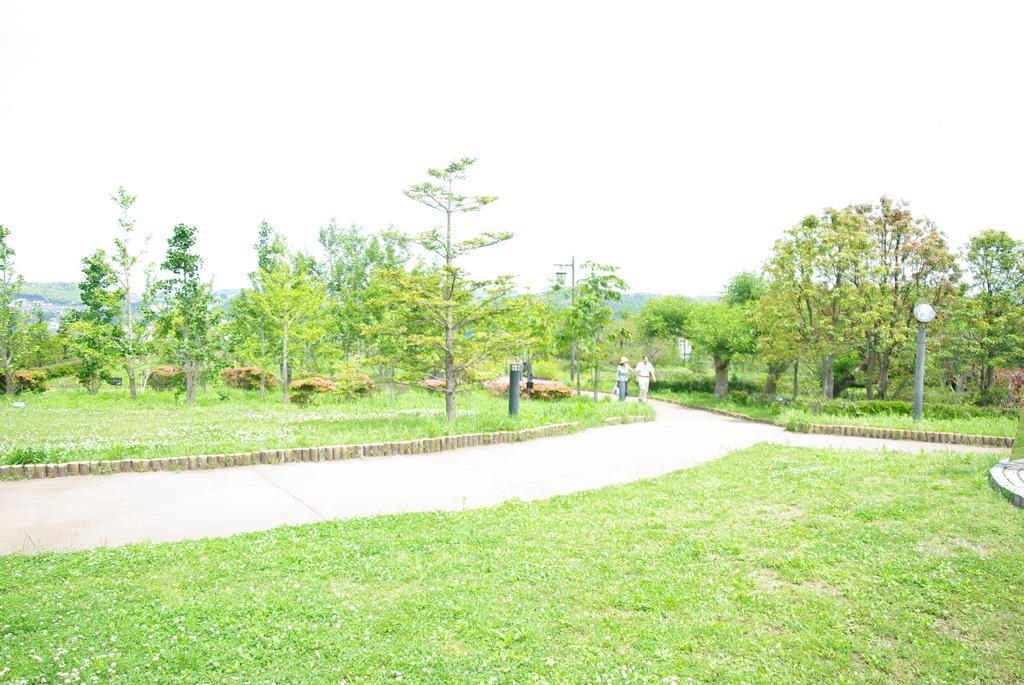Could you give a brief overview of what you see in this image? At the bottom of this image, there is grass on the ground. In the background, there are two persons walking on a road. On both sides of this road, there are trees, plants and grass on the ground. In the background, there are trees and there are clouds in the sky. 